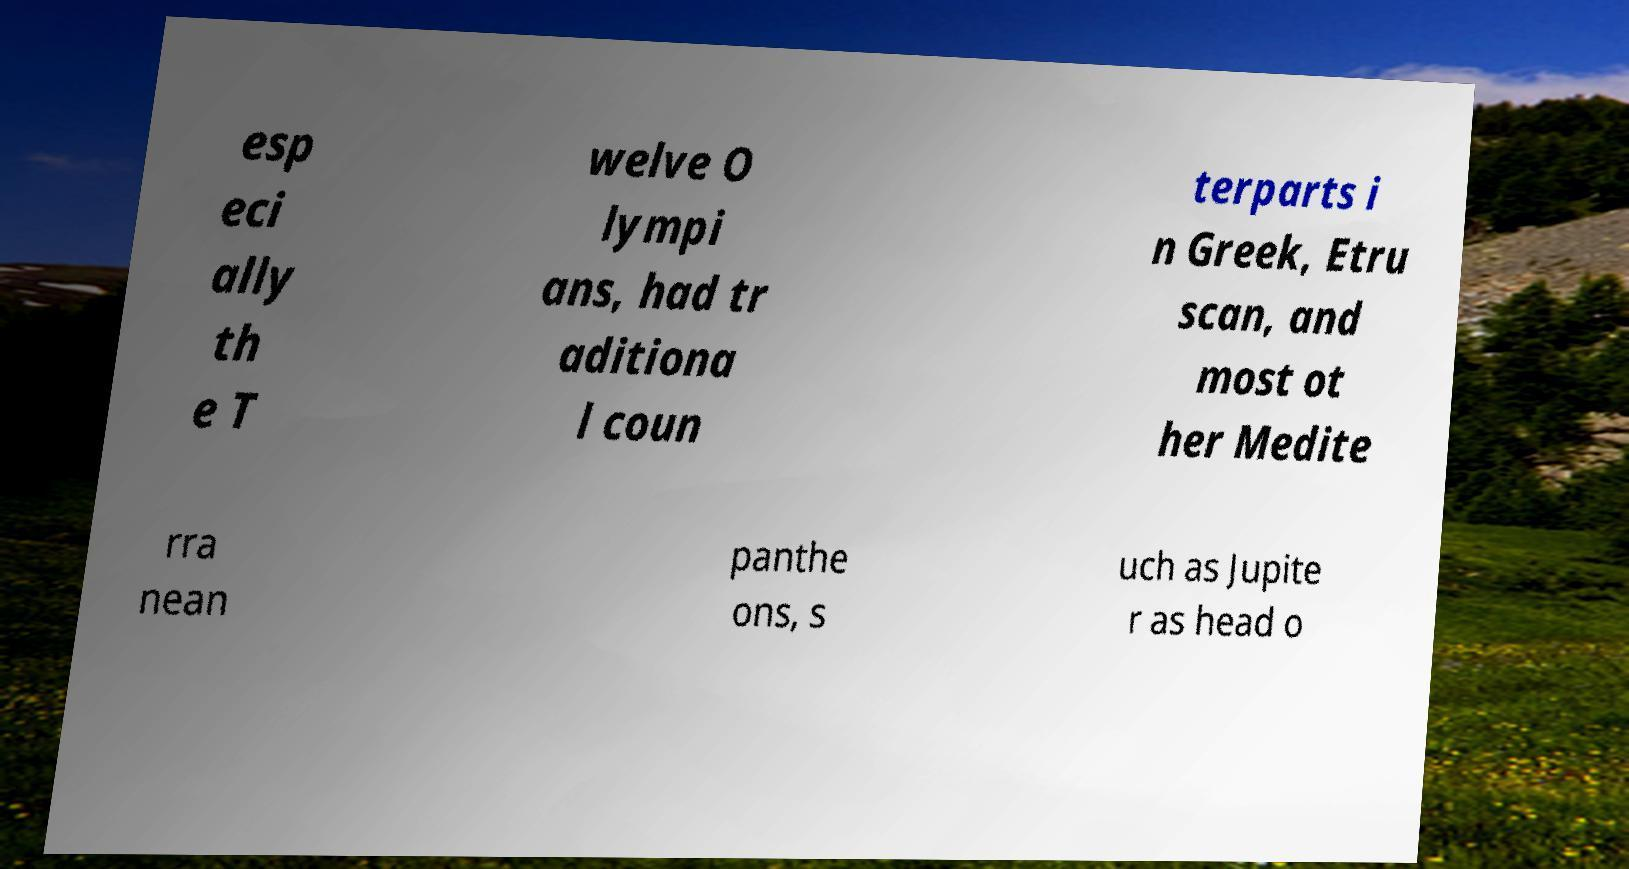For documentation purposes, I need the text within this image transcribed. Could you provide that? esp eci ally th e T welve O lympi ans, had tr aditiona l coun terparts i n Greek, Etru scan, and most ot her Medite rra nean panthe ons, s uch as Jupite r as head o 